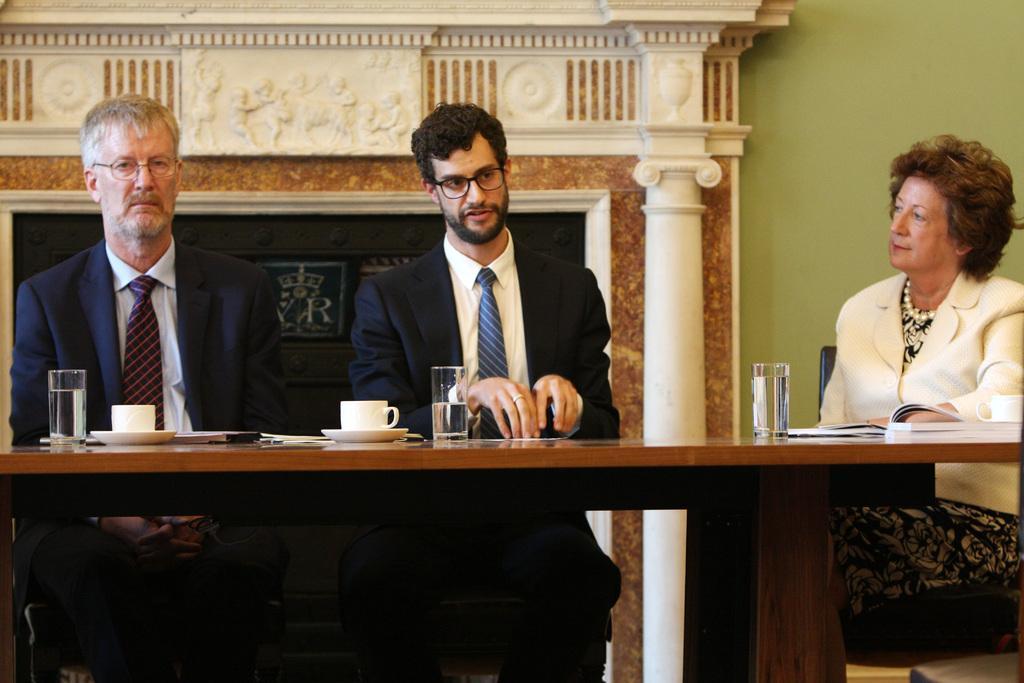Could you give a brief overview of what you see in this image? in this picture three people sitting on chairs. In front of them there is a table. On it there are glasses, cup and paper. Out of the three two are men who are sitting on the left the lady is sitting in the right. Both the men are wearing suits. The lady is wearing a white coat. On the background there is wall. 